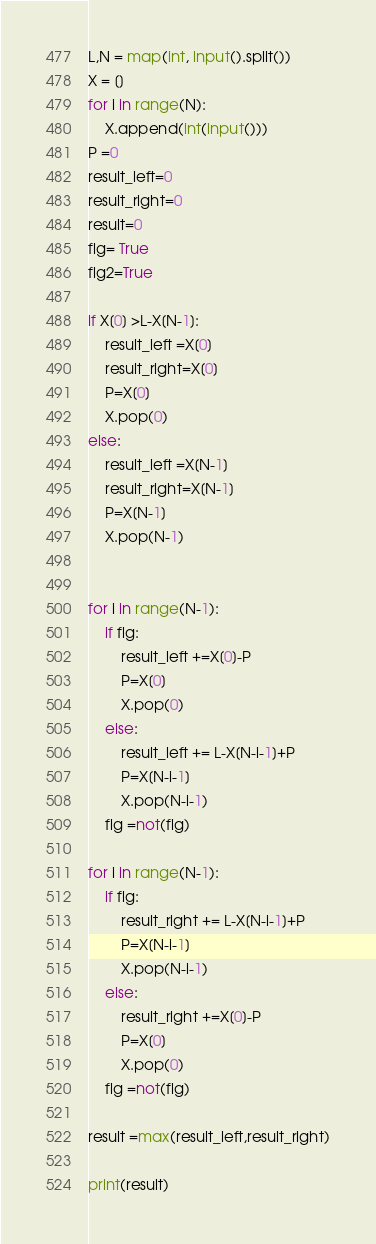Convert code to text. <code><loc_0><loc_0><loc_500><loc_500><_Python_>L,N = map(int, input().split()) 
X = []
for i in range(N):
    X.append(int(input())) 
P =0
result_left=0
result_right=0
result=0
flg= True
flg2=True

if X[0] >L-X[N-1]:
    result_left =X[0]
    result_right=X[0]
    P=X[0]
    X.pop(0)
else:
    result_left =X[N-1]
    result_right=X[N-1]
    P=X[N-1]
    X.pop(N-1)


for i in range(N-1):
    if flg:
        result_left +=X[0]-P
        P=X[0]
        X.pop(0)
    else:
        result_left += L-X[N-i-1]+P
        P=X[N-i-1]
        X.pop(N-i-1)
    flg =not(flg)

for i in range(N-1):
    if flg:
        result_right += L-X[N-i-1]+P
        P=X[N-i-1]
        X.pop(N-i-1)
    else:
        result_right +=X[0]-P
        P=X[0]
        X.pop(0)
    flg =not(flg)

result =max(result_left,result_right)

print(result)


</code> 